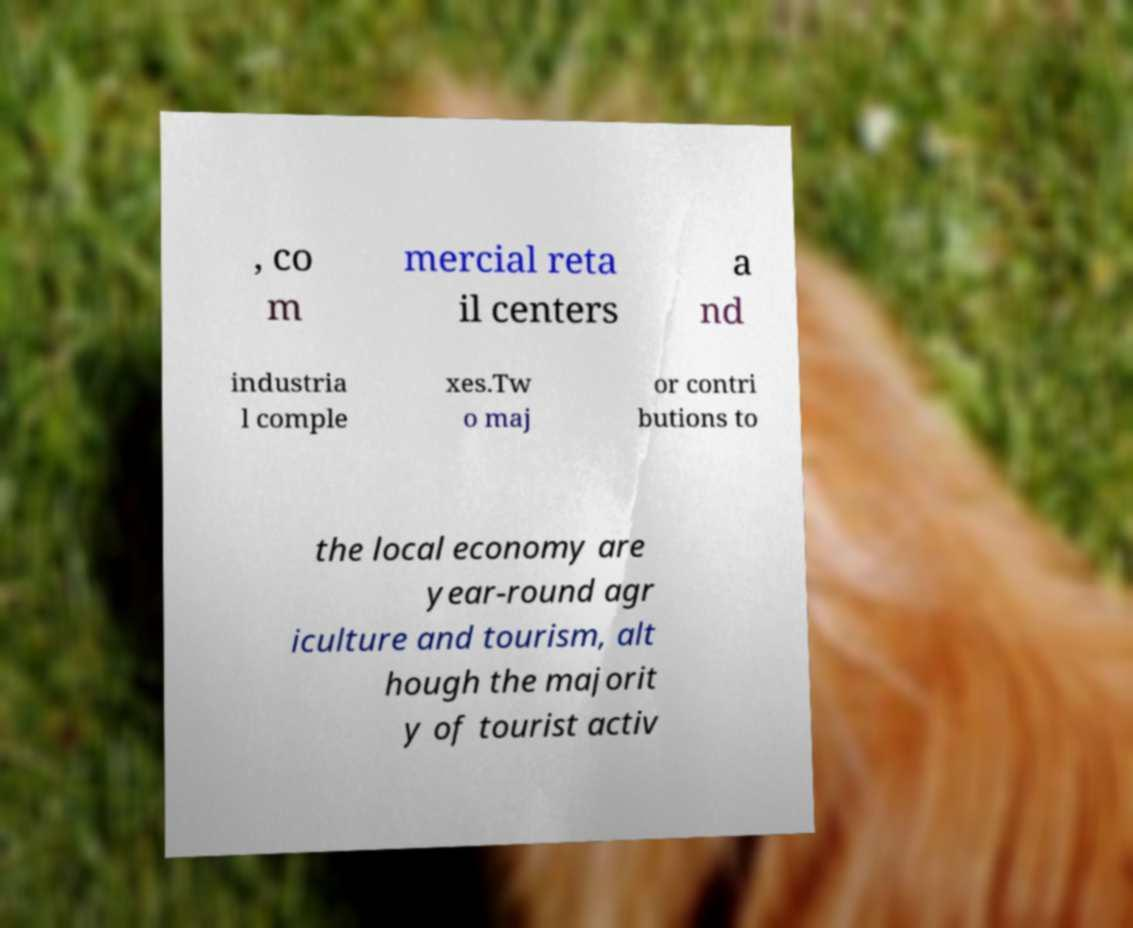Can you accurately transcribe the text from the provided image for me? , co m mercial reta il centers a nd industria l comple xes.Tw o maj or contri butions to the local economy are year-round agr iculture and tourism, alt hough the majorit y of tourist activ 